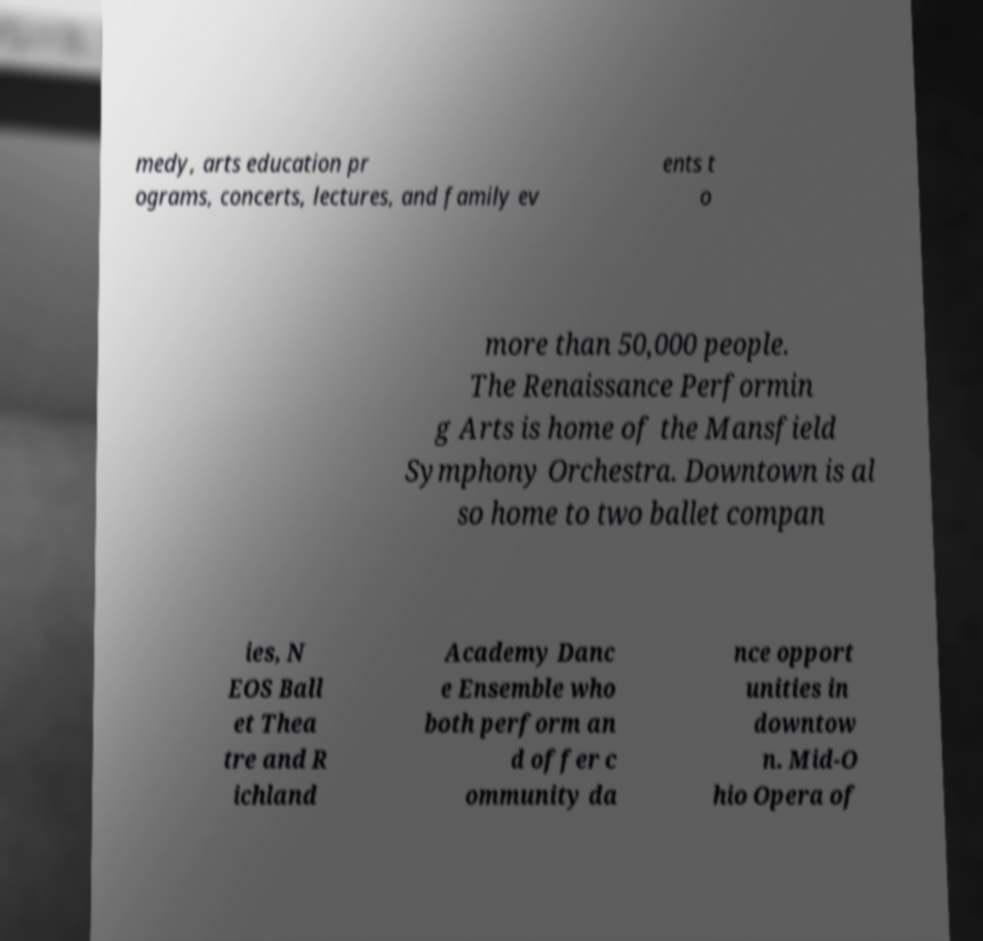Please identify and transcribe the text found in this image. medy, arts education pr ograms, concerts, lectures, and family ev ents t o more than 50,000 people. The Renaissance Performin g Arts is home of the Mansfield Symphony Orchestra. Downtown is al so home to two ballet compan ies, N EOS Ball et Thea tre and R ichland Academy Danc e Ensemble who both perform an d offer c ommunity da nce opport unities in downtow n. Mid-O hio Opera of 